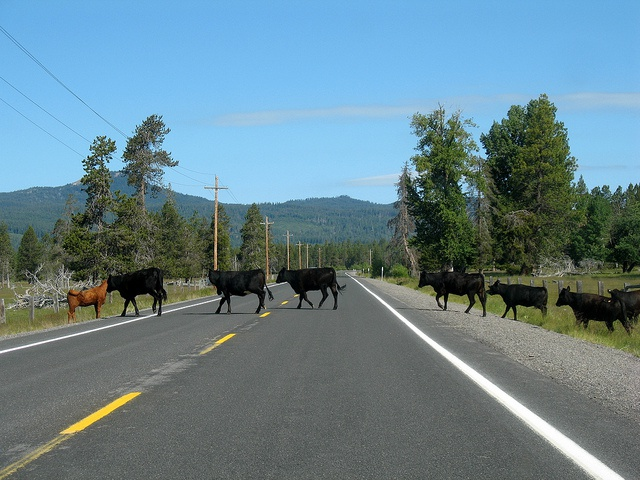Describe the objects in this image and their specific colors. I can see cow in lightblue, black, gray, darkgreen, and olive tones, cow in lightblue, black, darkgreen, and olive tones, cow in lightblue, black, darkgreen, gray, and darkgray tones, cow in lightblue, black, gray, and darkgreen tones, and cow in lightblue, black, gray, and darkgreen tones in this image. 